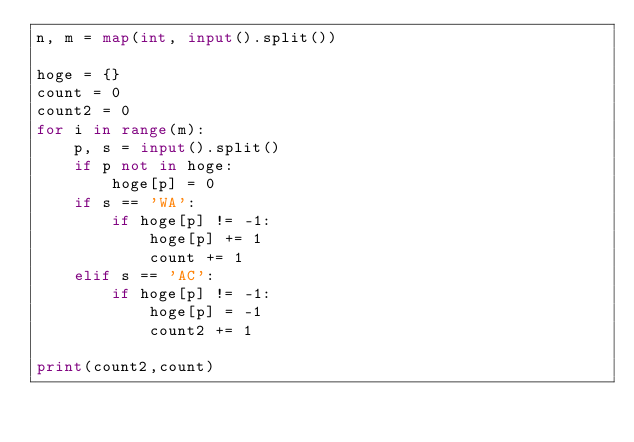<code> <loc_0><loc_0><loc_500><loc_500><_Python_>n, m = map(int, input().split())

hoge = {}
count = 0
count2 = 0
for i in range(m):
    p, s = input().split()
    if p not in hoge:
        hoge[p] = 0
    if s == 'WA':
        if hoge[p] != -1:
            hoge[p] += 1
            count += 1
    elif s == 'AC':
        if hoge[p] != -1:
            hoge[p] = -1
            count2 += 1

print(count2,count)</code> 